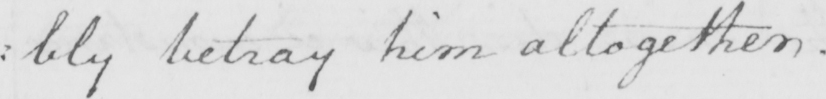What does this handwritten line say? : bly betray him altogether . 